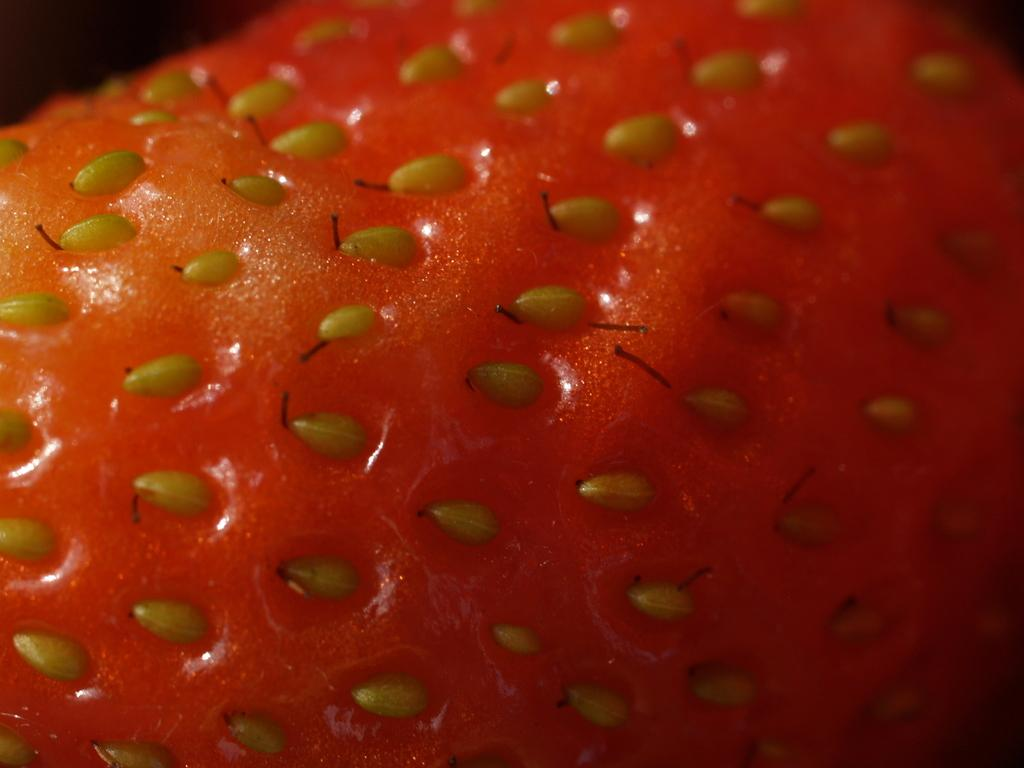What is the main subject of the image? The main subject of the image is a strawberry. Can you describe the describe the appearance of the strawberry? The image contains a close picture of a strawberry, so it is likely that the strawberry is the focus of the image. What type of coal is visible in the image? There is no coal present in the image; it features a close picture of a strawberry. What type of locket is hanging from the strawberry in the image? There is no locket present in the image; it features a close picture of a strawberry. 